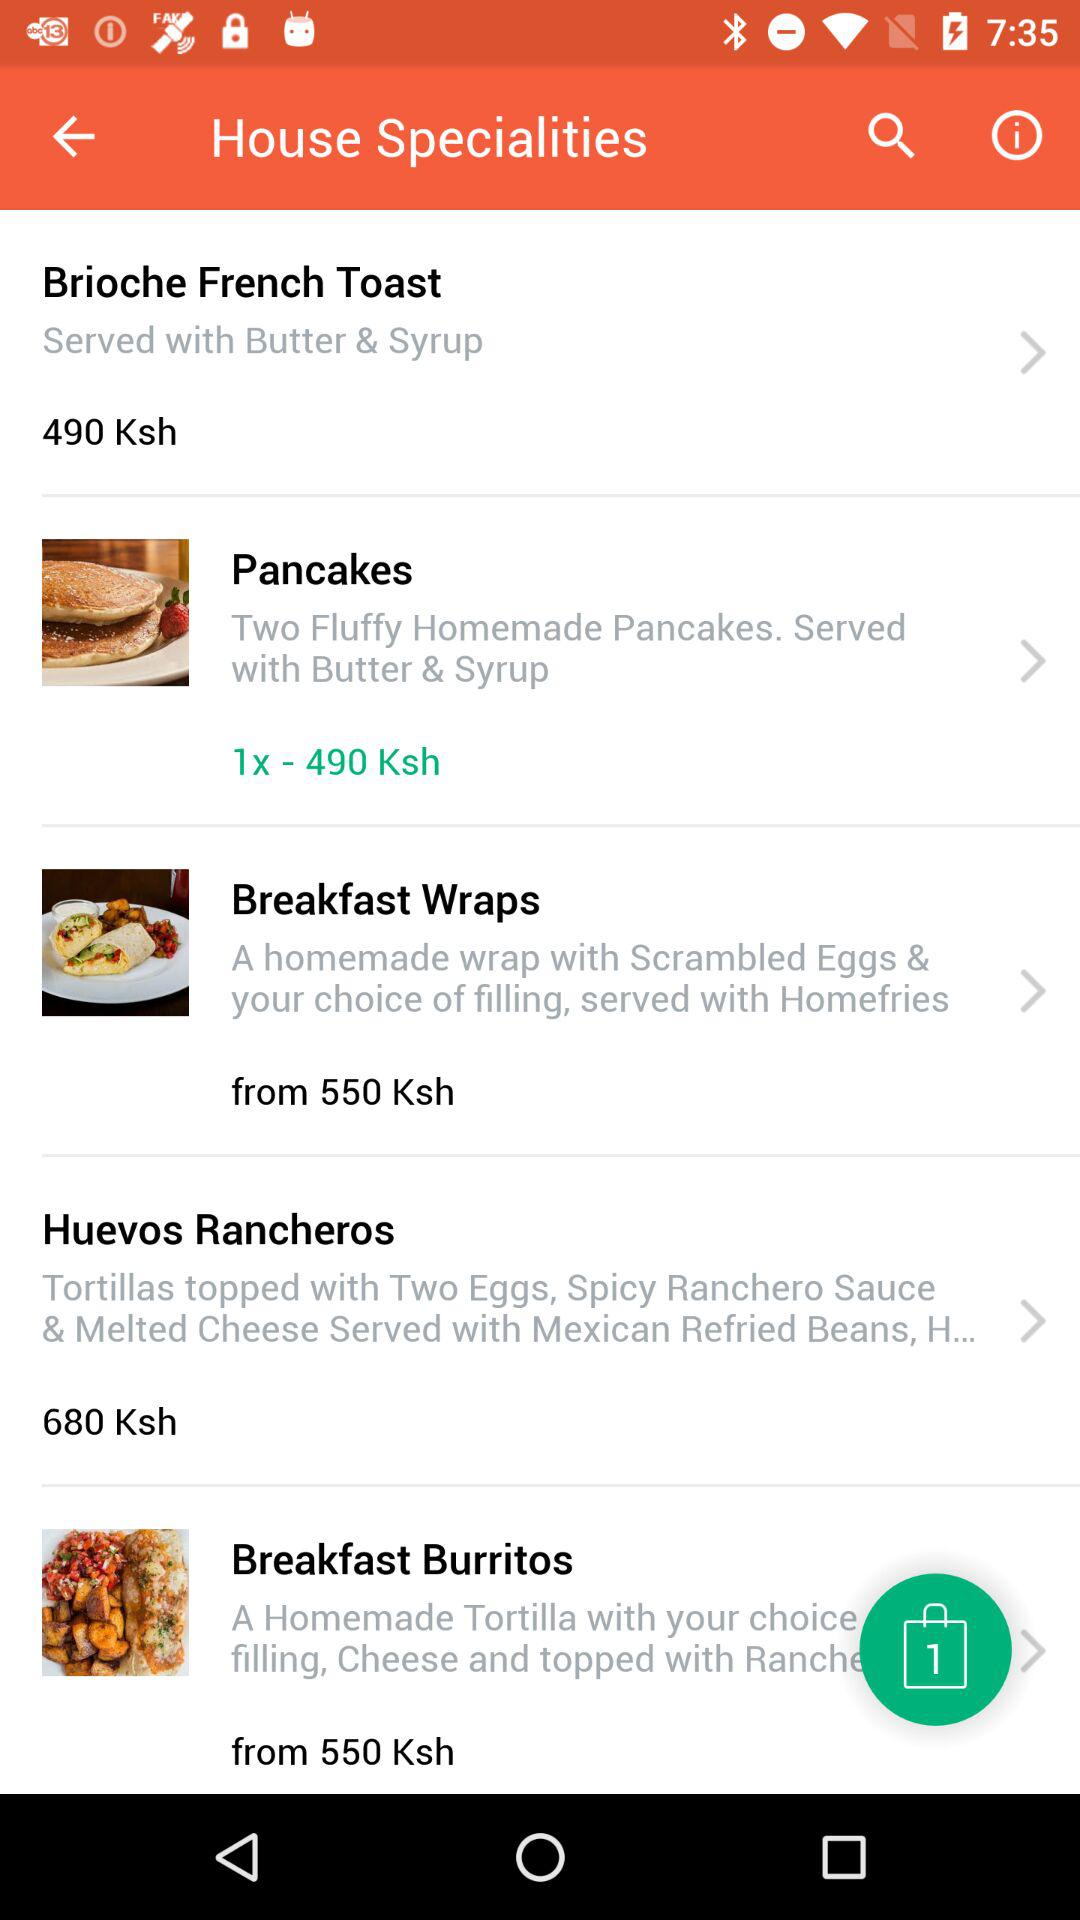What is the count of items in the bag? There is 1 item in the bag. 